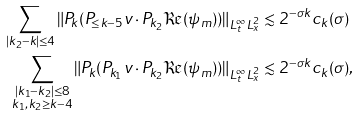Convert formula to latex. <formula><loc_0><loc_0><loc_500><loc_500>\sum _ { | k _ { 2 } - k | \leq 4 } \| P _ { k } ( P _ { \leq k - 5 } v \cdot P _ { k _ { 2 } } \Re ( \psi _ { m } ) ) \| _ { L _ { t } ^ { \infty } L _ { x } ^ { 2 } } & \lesssim 2 ^ { - \sigma k } c _ { k } ( \sigma ) \\ \sum _ { \substack { | k _ { 1 } - k _ { 2 } | \leq 8 \\ k _ { 1 } , k _ { 2 } \geq k - 4 } } \| P _ { k } ( P _ { k _ { 1 } } v \cdot P _ { k _ { 2 } } \Re ( \psi _ { m } ) ) \| _ { L _ { t } ^ { \infty } L _ { x } ^ { 2 } } & \lesssim 2 ^ { - \sigma k } c _ { k } ( \sigma ) ,</formula> 